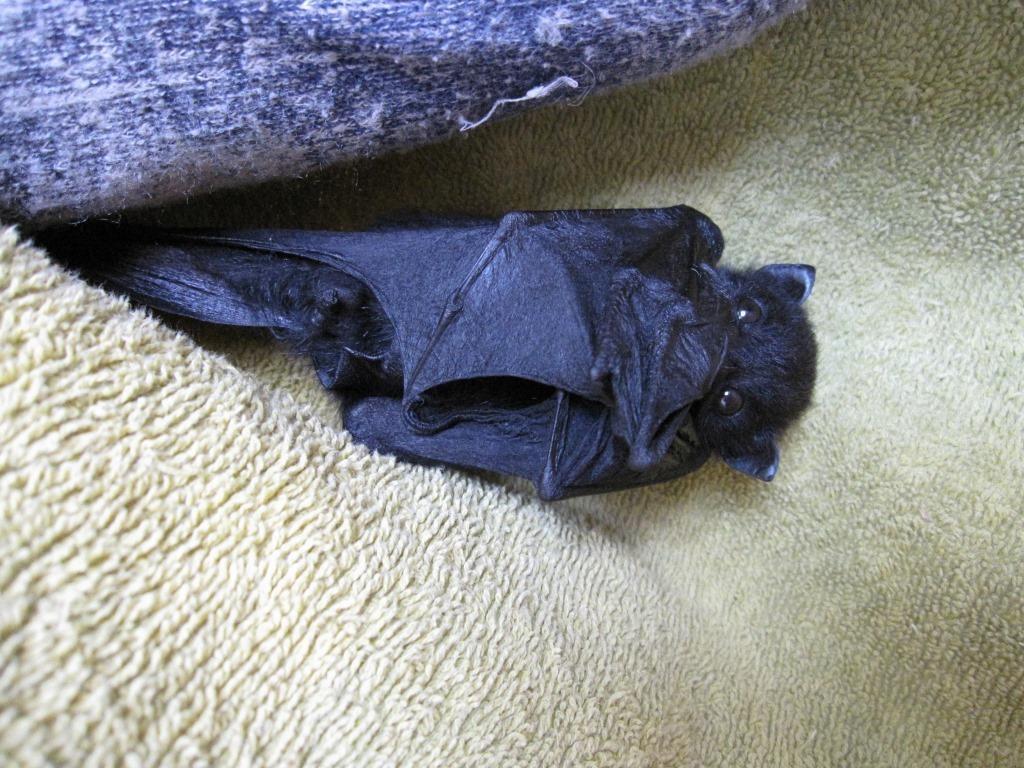Describe this image in one or two sentences. This image consists of a bat in black color. At the bottom, there is towel. At the top, there is a blanket. 